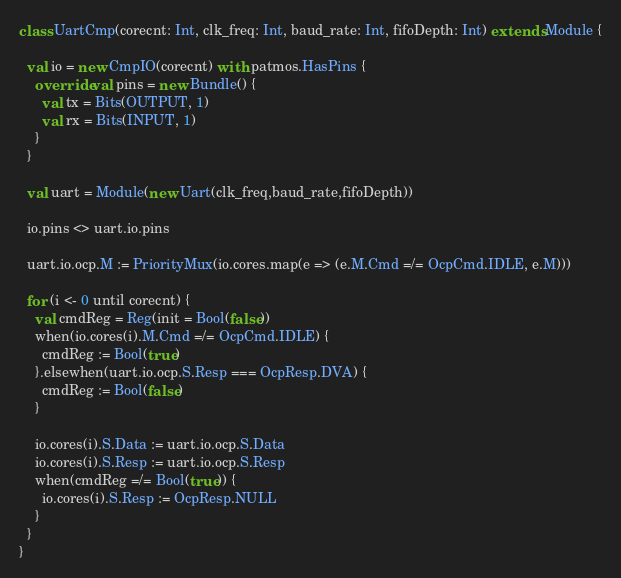<code> <loc_0><loc_0><loc_500><loc_500><_Scala_>class UartCmp(corecnt: Int, clk_freq: Int, baud_rate: Int, fifoDepth: Int) extends Module {

  val io = new CmpIO(corecnt) with patmos.HasPins {
    override val pins = new Bundle() {
      val tx = Bits(OUTPUT, 1)
      val rx = Bits(INPUT, 1)
    }
  }
  
  val uart = Module(new Uart(clk_freq,baud_rate,fifoDepth))
  
  io.pins <> uart.io.pins

  uart.io.ocp.M := PriorityMux(io.cores.map(e => (e.M.Cmd =/= OcpCmd.IDLE, e.M)))
  
  for (i <- 0 until corecnt) {
    val cmdReg = Reg(init = Bool(false))
    when(io.cores(i).M.Cmd =/= OcpCmd.IDLE) {
      cmdReg := Bool(true)
    }.elsewhen(uart.io.ocp.S.Resp === OcpResp.DVA) {
      cmdReg := Bool(false)
    }
    
    io.cores(i).S.Data := uart.io.ocp.S.Data
    io.cores(i).S.Resp := uart.io.ocp.S.Resp
    when(cmdReg =/= Bool(true)) {
      io.cores(i).S.Resp := OcpResp.NULL
    }
  }
}
</code> 